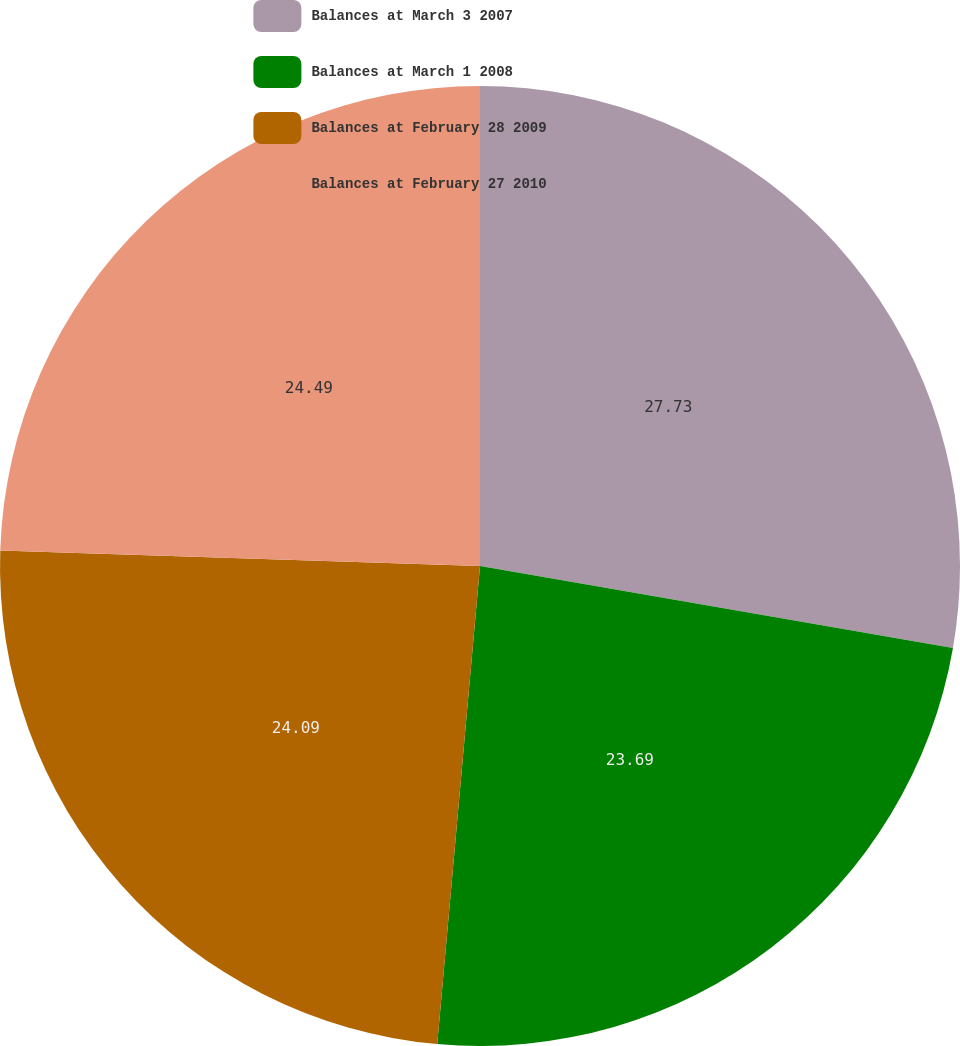Convert chart to OTSL. <chart><loc_0><loc_0><loc_500><loc_500><pie_chart><fcel>Balances at March 3 2007<fcel>Balances at March 1 2008<fcel>Balances at February 28 2009<fcel>Balances at February 27 2010<nl><fcel>27.73%<fcel>23.69%<fcel>24.09%<fcel>24.49%<nl></chart> 